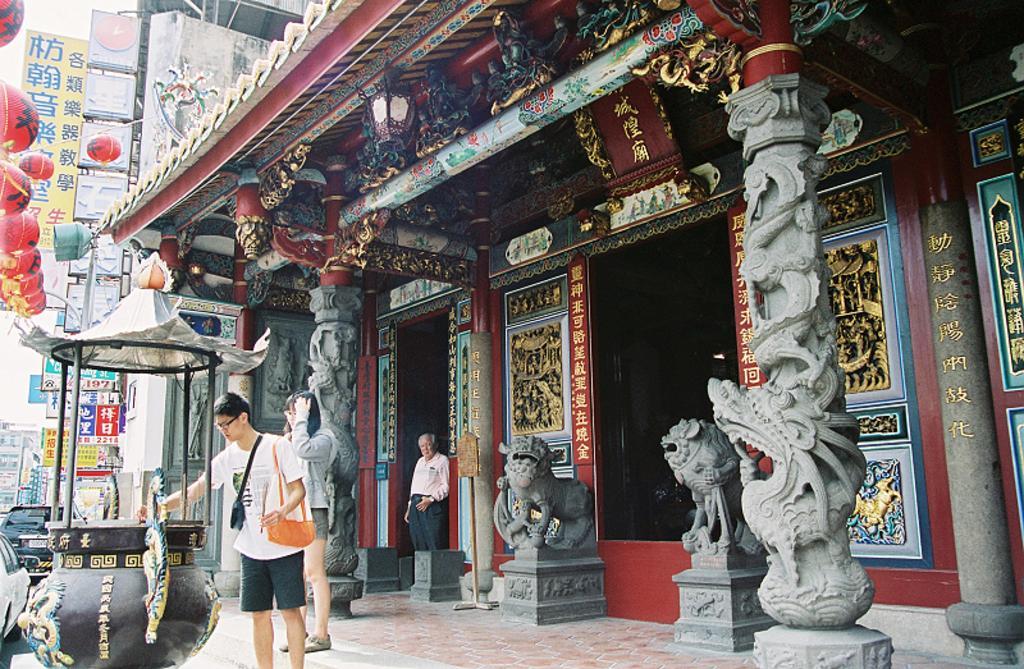In one or two sentences, can you explain what this image depicts? In this image there is a temple with sculptures , two persons are standing near the pot, another person standing near the door of a temple, and in the background there are name boards ,buildings, vehicles, paper lanterns,sky. 